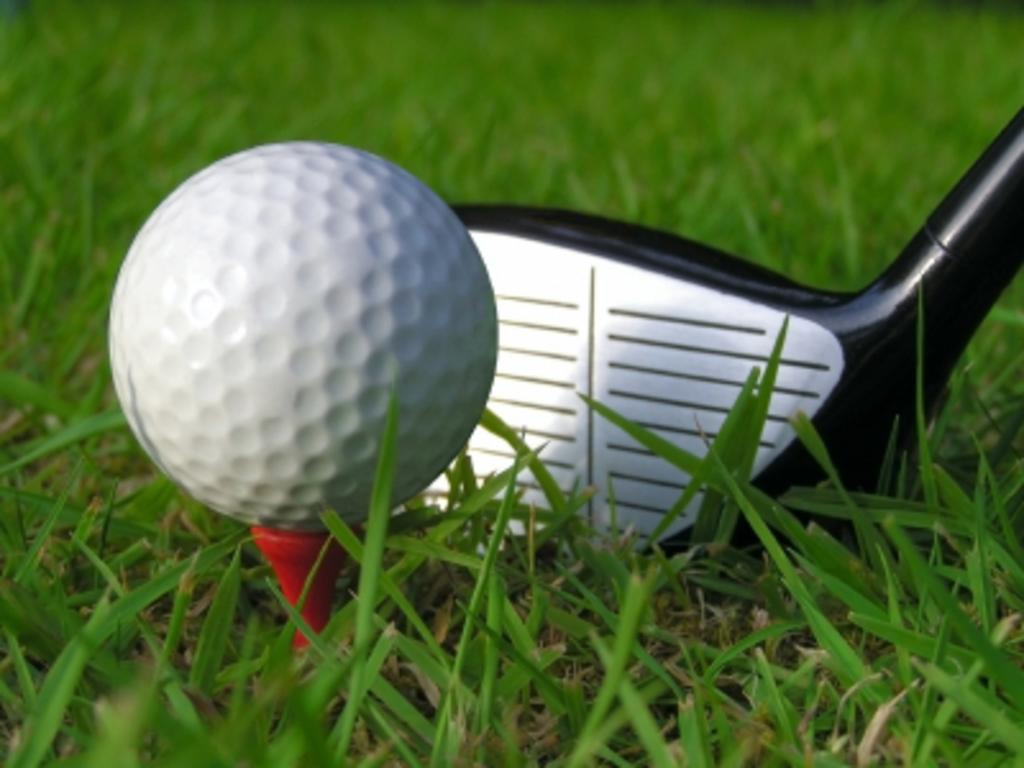What object is located on the left side of the image? There is a golf ball on the left side of the image. What object is located on the right side of the image? There is a bat on the right side of the image. What type of environment is depicted in the background of the image? There is grass in the background of the image. How many cats can be seen playing with the bat in the image? There are no cats present in the image, and therefore no such activity can be observed. 